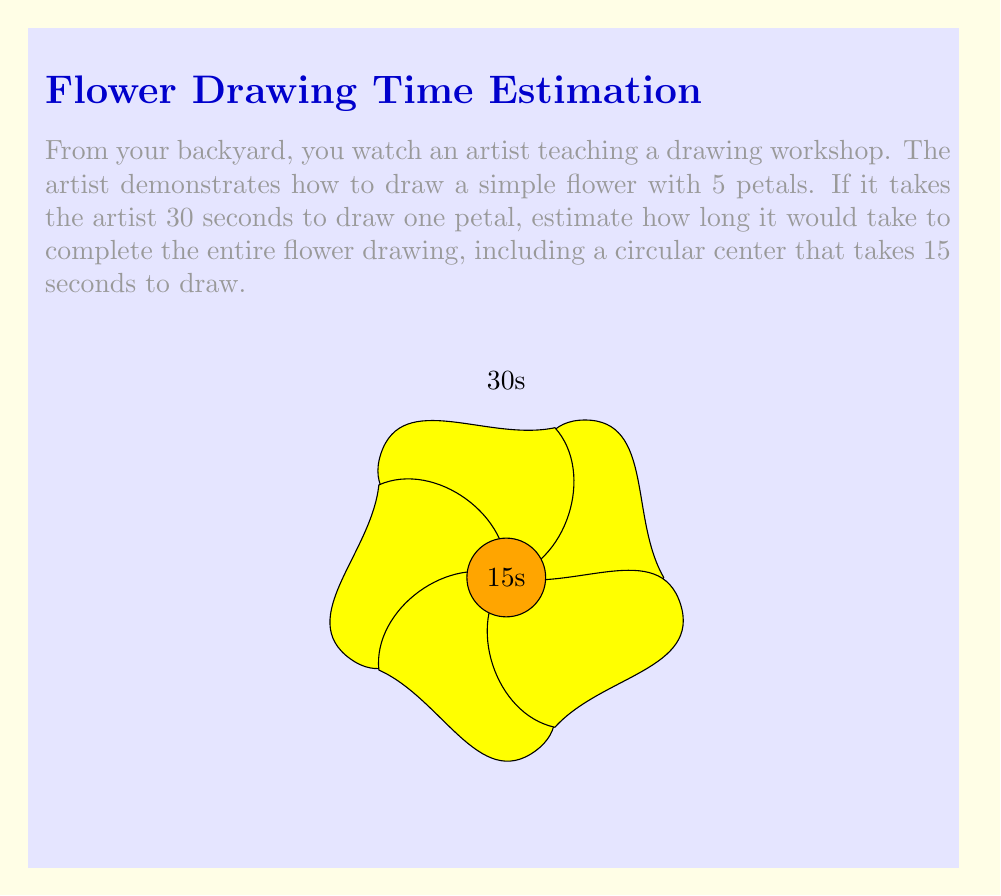Show me your answer to this math problem. Let's break down the problem step-by-step:

1) First, we need to calculate the time taken to draw all the petals:
   - Each petal takes 30 seconds
   - There are 5 petals in total
   - Time for petals = $5 \times 30 = 150$ seconds

2) Now, we add the time taken to draw the circular center:
   - The center takes 15 seconds

3) Total time is the sum of time for petals and center:
   $$ \text{Total time} = \text{Time for petals} + \text{Time for center} $$
   $$ \text{Total time} = 150 \text{ seconds} + 15 \text{ seconds} = 165 \text{ seconds} $$

4) To convert seconds to minutes and seconds:
   - 165 seconds = 2 minutes and 45 seconds
   $$ 165 \div 60 = 2 \text{ remainder } 45 $$

Therefore, it would take the artist 2 minutes and 45 seconds to complete the entire flower drawing.
Answer: 2 minutes and 45 seconds 